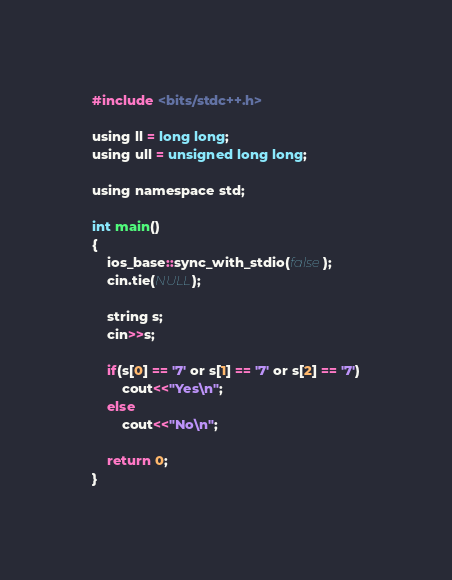Convert code to text. <code><loc_0><loc_0><loc_500><loc_500><_C_>#include <bits/stdc++.h>

using ll = long long;
using ull = unsigned long long;

using namespace std;

int main()
{
    ios_base::sync_with_stdio(false);
    cin.tie(NULL);

    string s;
    cin>>s;

    if(s[0] == '7' or s[1] == '7' or s[2] == '7')
        cout<<"Yes\n";
    else
        cout<<"No\n";

    return 0;
}</code> 